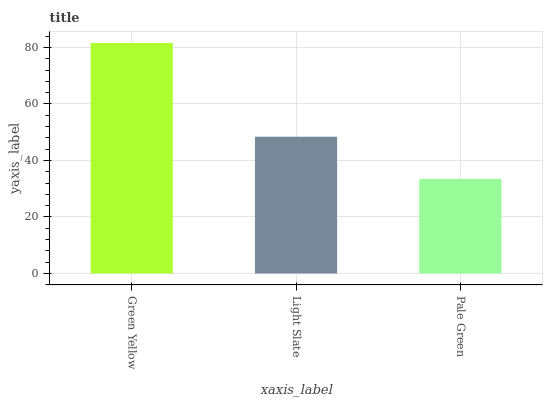Is Pale Green the minimum?
Answer yes or no. Yes. Is Green Yellow the maximum?
Answer yes or no. Yes. Is Light Slate the minimum?
Answer yes or no. No. Is Light Slate the maximum?
Answer yes or no. No. Is Green Yellow greater than Light Slate?
Answer yes or no. Yes. Is Light Slate less than Green Yellow?
Answer yes or no. Yes. Is Light Slate greater than Green Yellow?
Answer yes or no. No. Is Green Yellow less than Light Slate?
Answer yes or no. No. Is Light Slate the high median?
Answer yes or no. Yes. Is Light Slate the low median?
Answer yes or no. Yes. Is Pale Green the high median?
Answer yes or no. No. Is Pale Green the low median?
Answer yes or no. No. 